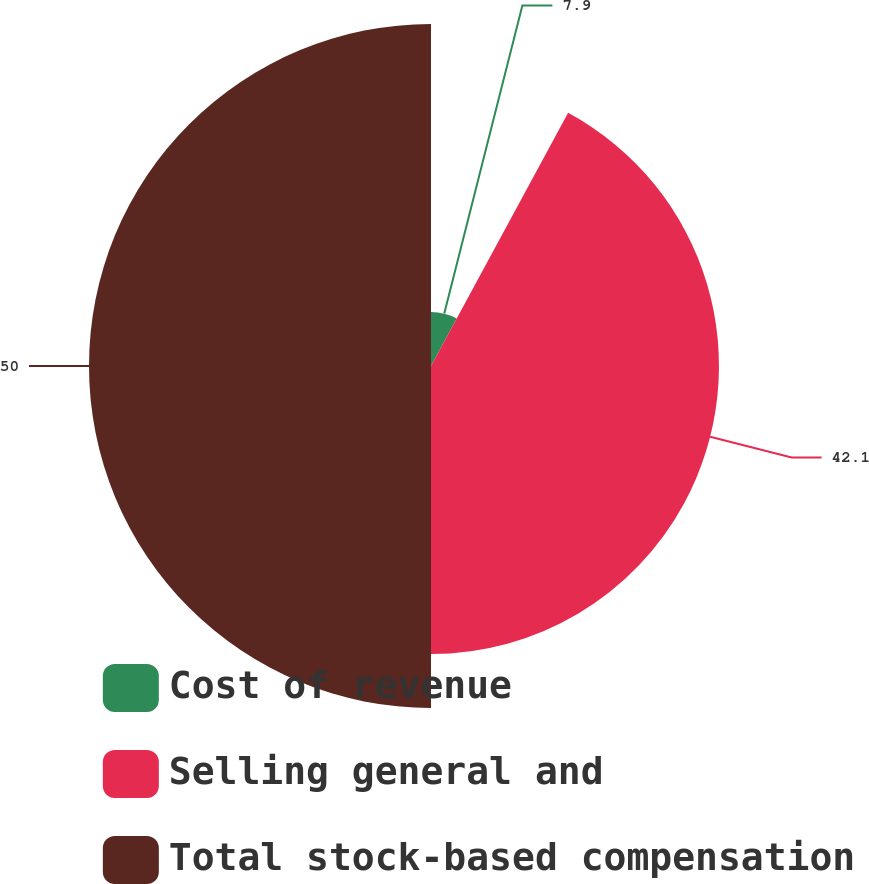<chart> <loc_0><loc_0><loc_500><loc_500><pie_chart><fcel>Cost of revenue<fcel>Selling general and<fcel>Total stock-based compensation<nl><fcel>7.9%<fcel>42.1%<fcel>50.0%<nl></chart> 